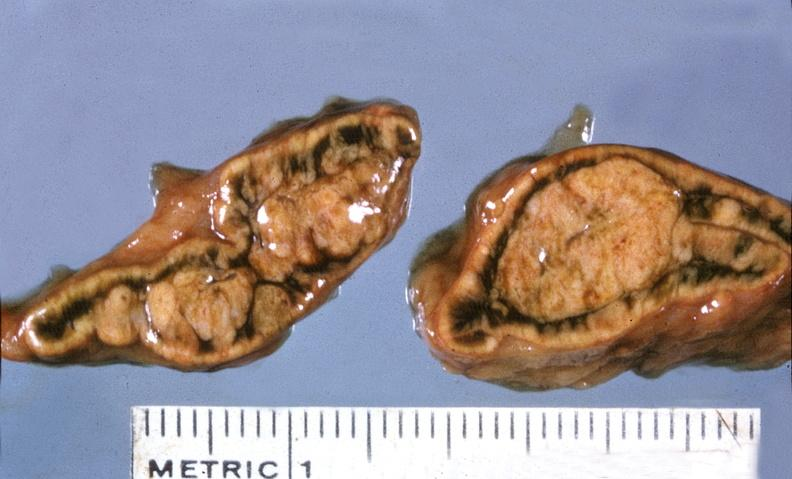what is present?
Answer the question using a single word or phrase. Endocrine 